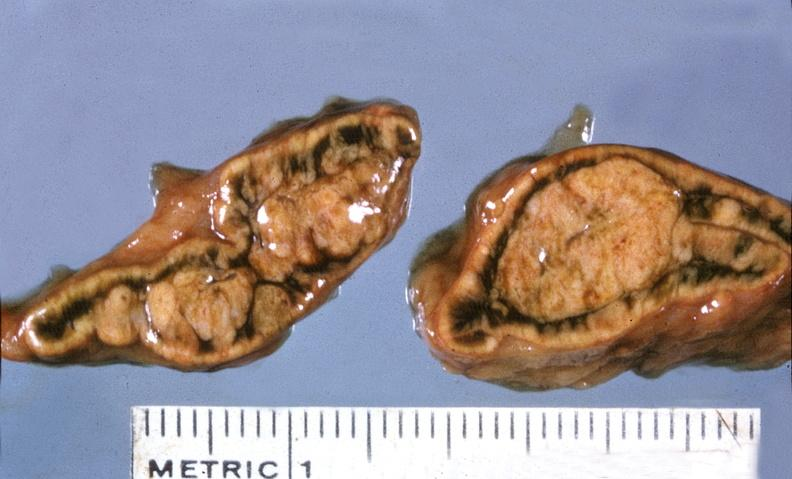what is present?
Answer the question using a single word or phrase. Endocrine 